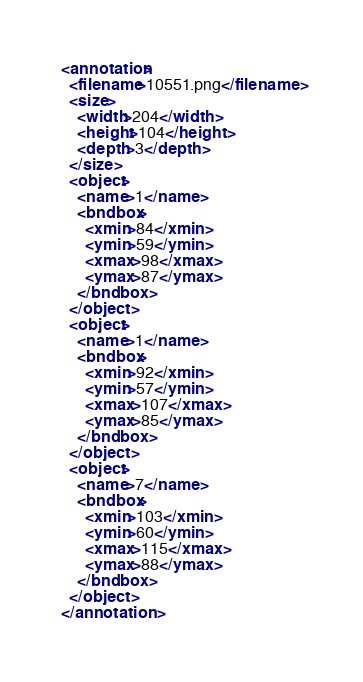<code> <loc_0><loc_0><loc_500><loc_500><_XML_><annotation>
  <filename>10551.png</filename>
  <size>
    <width>204</width>
    <height>104</height>
    <depth>3</depth>
  </size>
  <object>
    <name>1</name>
    <bndbox>
      <xmin>84</xmin>
      <ymin>59</ymin>
      <xmax>98</xmax>
      <ymax>87</ymax>
    </bndbox>
  </object>
  <object>
    <name>1</name>
    <bndbox>
      <xmin>92</xmin>
      <ymin>57</ymin>
      <xmax>107</xmax>
      <ymax>85</ymax>
    </bndbox>
  </object>
  <object>
    <name>7</name>
    <bndbox>
      <xmin>103</xmin>
      <ymin>60</ymin>
      <xmax>115</xmax>
      <ymax>88</ymax>
    </bndbox>
  </object>
</annotation>
</code> 